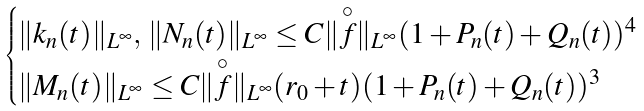Convert formula to latex. <formula><loc_0><loc_0><loc_500><loc_500>\begin{cases} \| k _ { n } ( t ) \| _ { L ^ { \infty } } , \, \| N _ { n } ( t ) \| _ { L ^ { \infty } } \leq C \| \overset { \circ } { f } \| _ { L ^ { \infty } } ( 1 + P _ { n } ( t ) + Q _ { n } ( t ) ) ^ { 4 } \\ \| M _ { n } ( t ) \| _ { L ^ { \infty } } \leq C \| \overset { \circ } { f } \| _ { L ^ { \infty } } ( r _ { 0 } + t ) ( 1 + P _ { n } ( t ) + Q _ { n } ( t ) ) ^ { 3 } \end{cases}</formula> 